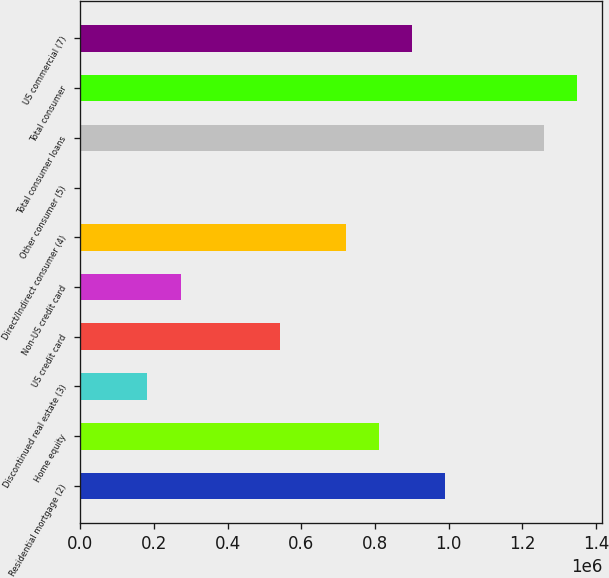<chart> <loc_0><loc_0><loc_500><loc_500><bar_chart><fcel>Residential mortgage (2)<fcel>Home equity<fcel>Discontinued real estate (3)<fcel>US credit card<fcel>Non-US credit card<fcel>Direct/Indirect consumer (4)<fcel>Other consumer (5)<fcel>Total consumer loans<fcel>Total consumer<fcel>US commercial (7)<nl><fcel>989830<fcel>810426<fcel>182514<fcel>541321<fcel>272215<fcel>720724<fcel>3110<fcel>1.25894e+06<fcel>1.34864e+06<fcel>900128<nl></chart> 